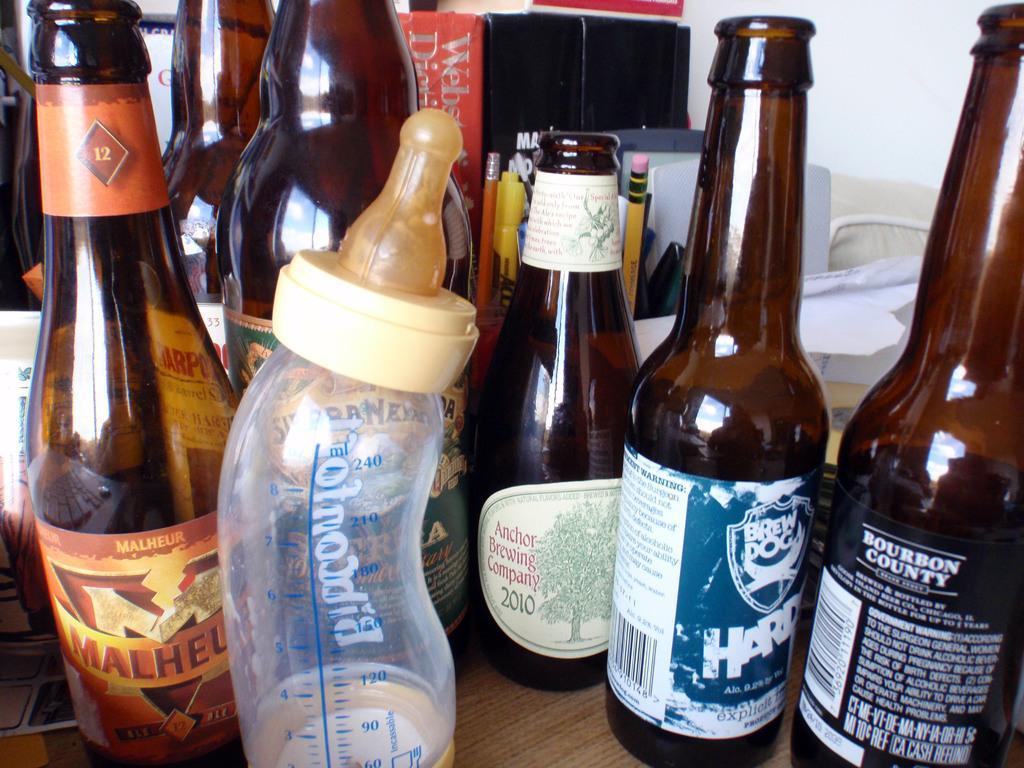How would you summarize this image in a sentence or two? This picture shows bottles on the table. 